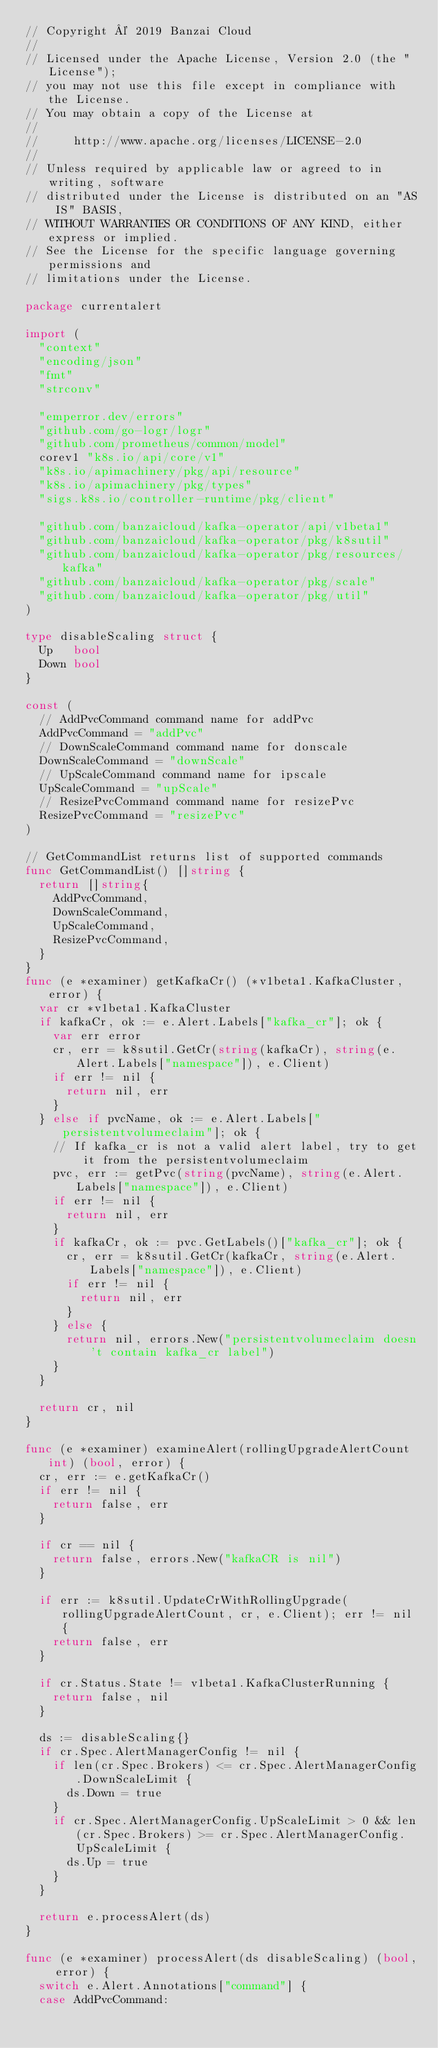<code> <loc_0><loc_0><loc_500><loc_500><_Go_>// Copyright © 2019 Banzai Cloud
//
// Licensed under the Apache License, Version 2.0 (the "License");
// you may not use this file except in compliance with the License.
// You may obtain a copy of the License at
//
//     http://www.apache.org/licenses/LICENSE-2.0
//
// Unless required by applicable law or agreed to in writing, software
// distributed under the License is distributed on an "AS IS" BASIS,
// WITHOUT WARRANTIES OR CONDITIONS OF ANY KIND, either express or implied.
// See the License for the specific language governing permissions and
// limitations under the License.

package currentalert

import (
	"context"
	"encoding/json"
	"fmt"
	"strconv"

	"emperror.dev/errors"
	"github.com/go-logr/logr"
	"github.com/prometheus/common/model"
	corev1 "k8s.io/api/core/v1"
	"k8s.io/apimachinery/pkg/api/resource"
	"k8s.io/apimachinery/pkg/types"
	"sigs.k8s.io/controller-runtime/pkg/client"

	"github.com/banzaicloud/kafka-operator/api/v1beta1"
	"github.com/banzaicloud/kafka-operator/pkg/k8sutil"
	"github.com/banzaicloud/kafka-operator/pkg/resources/kafka"
	"github.com/banzaicloud/kafka-operator/pkg/scale"
	"github.com/banzaicloud/kafka-operator/pkg/util"
)

type disableScaling struct {
	Up   bool
	Down bool
}

const (
	// AddPvcCommand command name for addPvc
	AddPvcCommand = "addPvc"
	// DownScaleCommand command name for donscale
	DownScaleCommand = "downScale"
	// UpScaleCommand command name for ipscale
	UpScaleCommand = "upScale"
	// ResizePvcCommand command name for resizePvc
	ResizePvcCommand = "resizePvc"
)

// GetCommandList returns list of supported commands
func GetCommandList() []string {
	return []string{
		AddPvcCommand,
		DownScaleCommand,
		UpScaleCommand,
		ResizePvcCommand,
	}
}
func (e *examiner) getKafkaCr() (*v1beta1.KafkaCluster, error) {
	var cr *v1beta1.KafkaCluster
	if kafkaCr, ok := e.Alert.Labels["kafka_cr"]; ok {
		var err error
		cr, err = k8sutil.GetCr(string(kafkaCr), string(e.Alert.Labels["namespace"]), e.Client)
		if err != nil {
			return nil, err
		}
	} else if pvcName, ok := e.Alert.Labels["persistentvolumeclaim"]; ok {
		// If kafka_cr is not a valid alert label, try to get it from the persistentvolumeclaim
		pvc, err := getPvc(string(pvcName), string(e.Alert.Labels["namespace"]), e.Client)
		if err != nil {
			return nil, err
		}
		if kafkaCr, ok := pvc.GetLabels()["kafka_cr"]; ok {
			cr, err = k8sutil.GetCr(kafkaCr, string(e.Alert.Labels["namespace"]), e.Client)
			if err != nil {
				return nil, err
			}
		} else {
			return nil, errors.New("persistentvolumeclaim doesn't contain kafka_cr label")
		}
	}

	return cr, nil
}

func (e *examiner) examineAlert(rollingUpgradeAlertCount int) (bool, error) {
	cr, err := e.getKafkaCr()
	if err != nil {
		return false, err
	}

	if cr == nil {
		return false, errors.New("kafkaCR is nil")
	}

	if err := k8sutil.UpdateCrWithRollingUpgrade(rollingUpgradeAlertCount, cr, e.Client); err != nil {
		return false, err
	}

	if cr.Status.State != v1beta1.KafkaClusterRunning {
		return false, nil
	}

	ds := disableScaling{}
	if cr.Spec.AlertManagerConfig != nil {
		if len(cr.Spec.Brokers) <= cr.Spec.AlertManagerConfig.DownScaleLimit {
			ds.Down = true
		}
		if cr.Spec.AlertManagerConfig.UpScaleLimit > 0 && len(cr.Spec.Brokers) >= cr.Spec.AlertManagerConfig.UpScaleLimit {
			ds.Up = true
		}
	}

	return e.processAlert(ds)
}

func (e *examiner) processAlert(ds disableScaling) (bool, error) {
	switch e.Alert.Annotations["command"] {
	case AddPvcCommand:</code> 